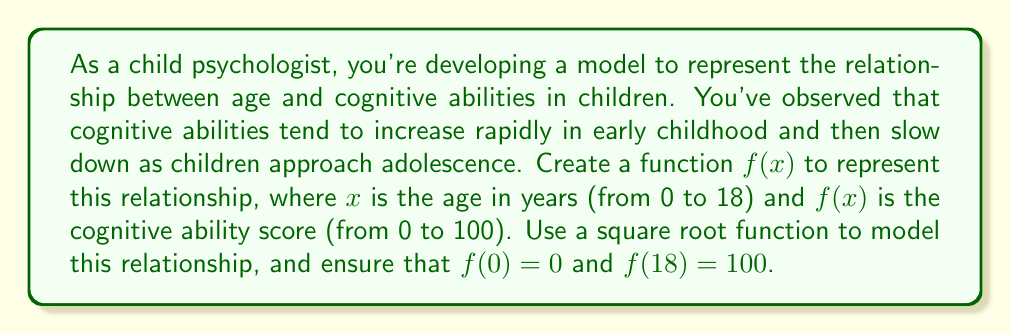Teach me how to tackle this problem. Let's approach this step-by-step:

1) We need a function of the form $f(x) = a\sqrt{x} + b$, where $a$ and $b$ are constants we need to determine.

2) We know two points that our function must pass through:
   - When $x = 0$, $f(x) = 0$
   - When $x = 18$, $f(x) = 100$

3) Let's use the first condition: $f(0) = 0$
   $0 = a\sqrt{0} + b$
   $0 = b$

4) So our function is now $f(x) = a\sqrt{x}$

5) Now let's use the second condition: $f(18) = 100$
   $100 = a\sqrt{18}$

6) Solve for $a$:
   $a = \frac{100}{\sqrt{18}} = \frac{100}{\sqrt{18}} \cdot \frac{\sqrt{18}}{\sqrt{18}} = \frac{100\sqrt{18}}{18} \approx 23.57$

7) Therefore, our final function is:

   $f(x) = \frac{100\sqrt{18}}{18}\sqrt{x} \approx 23.57\sqrt{x}$

This function will give a cognitive ability score of 0 at age 0, and 100 at age 18, with a rapidly increasing score in early years that slows down as the child approaches adolescence.
Answer: $f(x) = \frac{100\sqrt{18}}{18}\sqrt{x}$ 